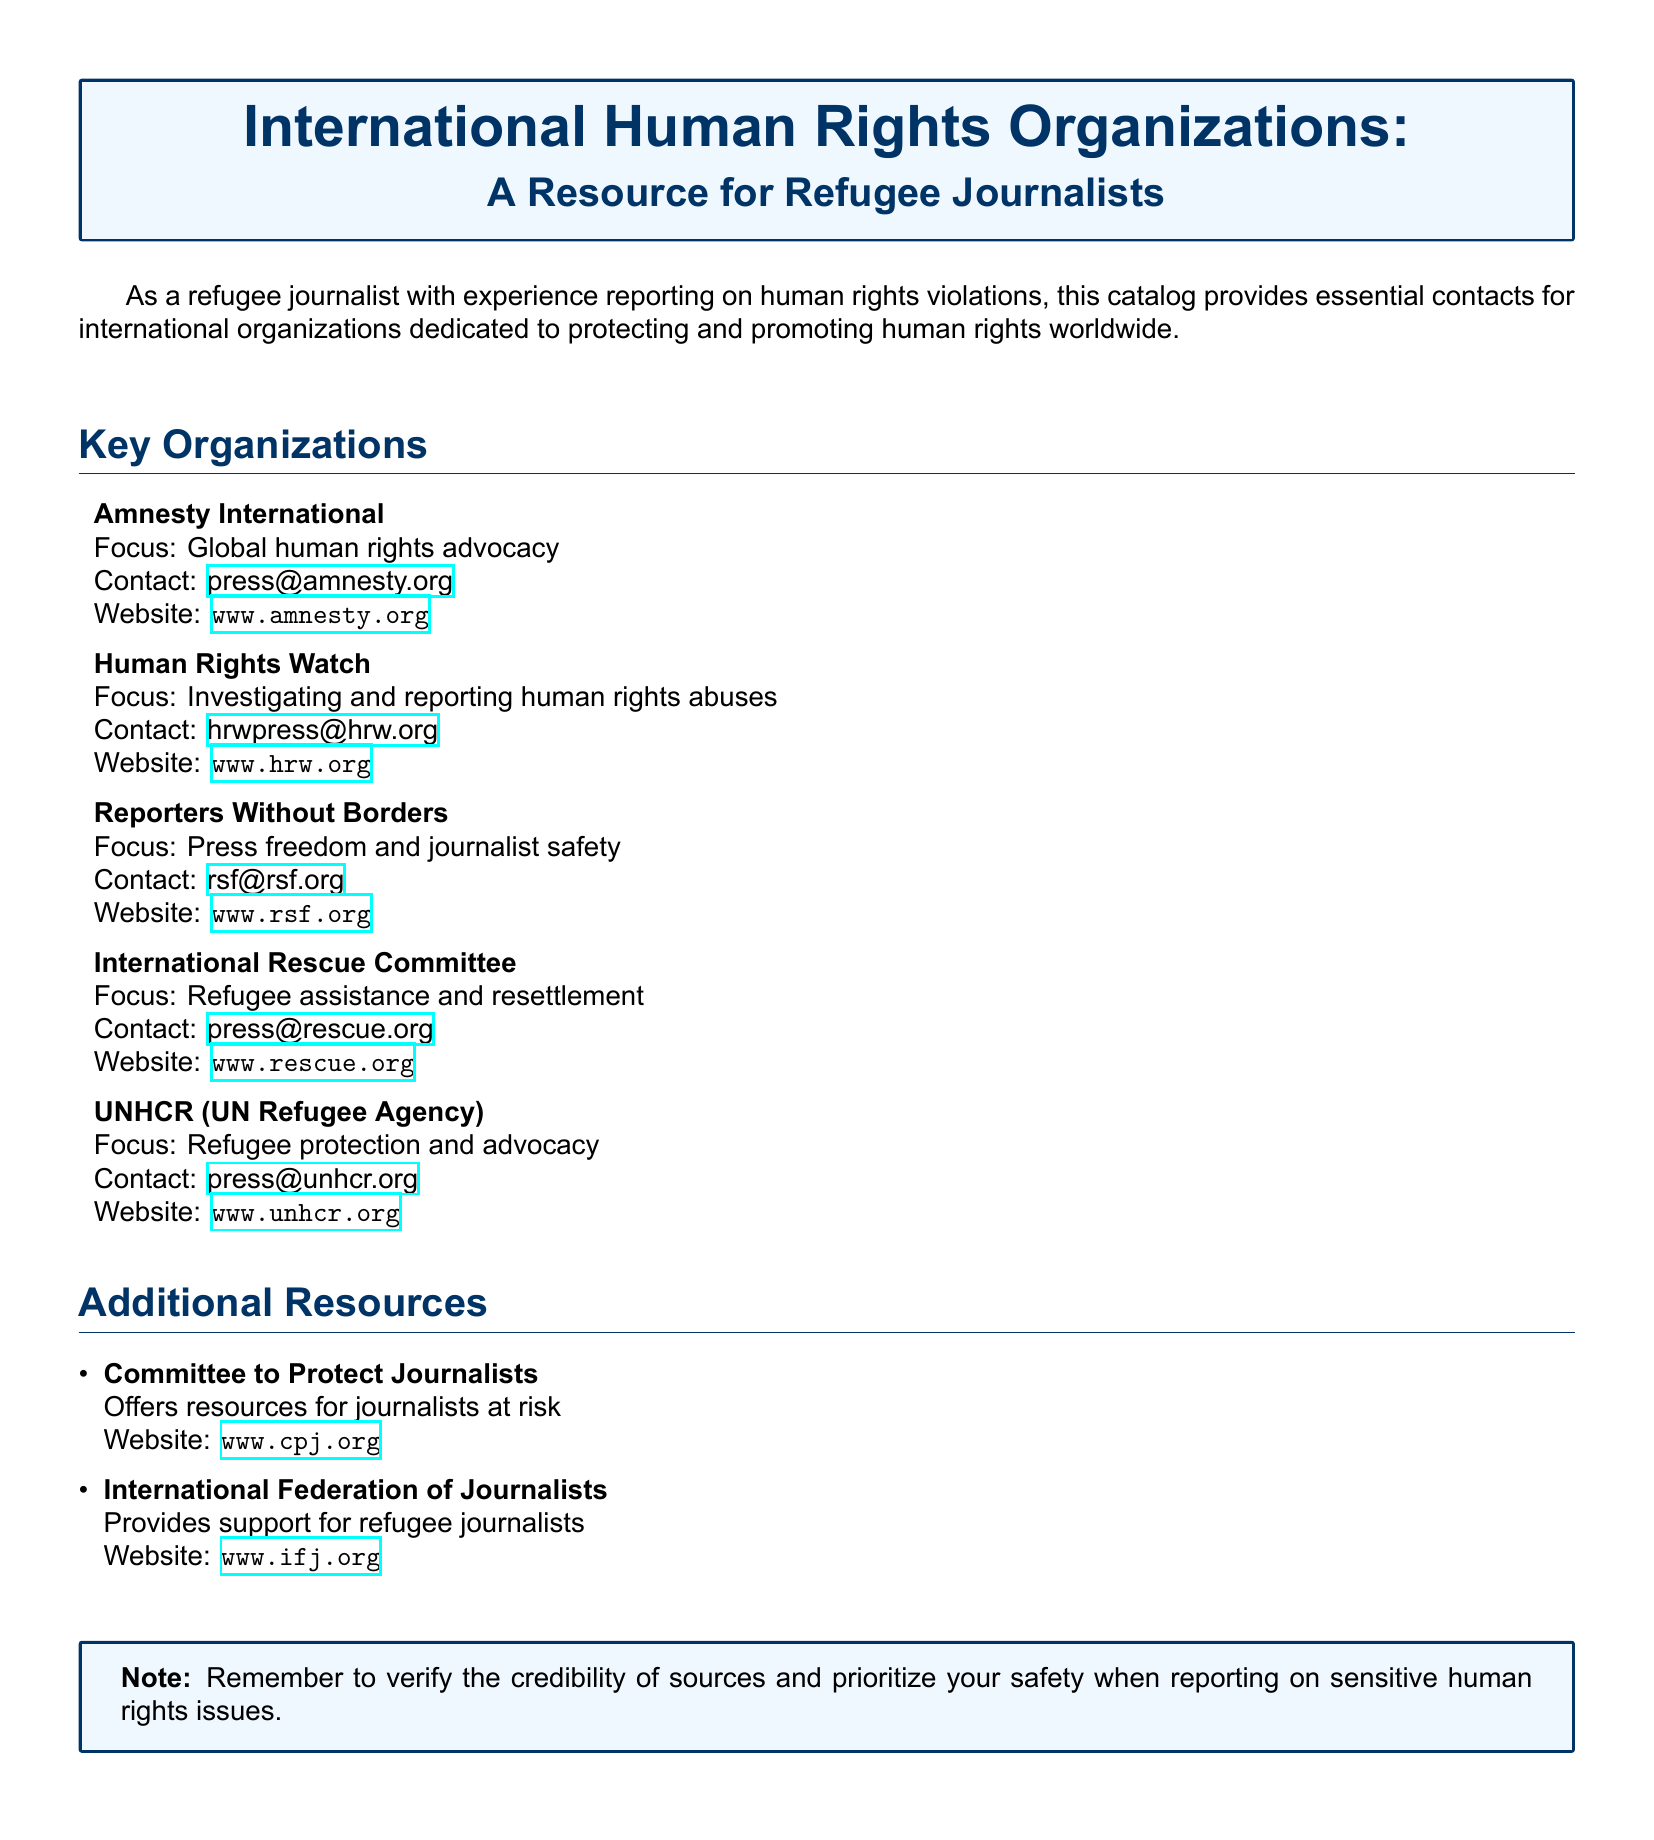What is the focus of Amnesty International? The focus of Amnesty International is global human rights advocacy.
Answer: Global human rights advocacy What is the contact email for Human Rights Watch? The contact email for Human Rights Watch is provided in the document.
Answer: hrwpress@hrw.org Which organization focuses on refugee protection? The organization that focuses on refugee protection is listed in the catalog.
Answer: UNHCR (UN Refugee Agency) How many key organizations are mentioned in the document? The document lists a specific number of key organizations under the "Key Organizations" section.
Answer: 5 What additional resources support refugee journalists? The document provides the names of organizations that offer additional resources for refugee journalists.
Answer: International Federation of Journalists What is the website for Reporters Without Borders? The website for Reporters Without Borders is included in the document.
Answer: www.rsf.org What is the main focus of the International Rescue Committee? The main focus of the International Rescue Committee is mentioned in the document.
Answer: Refugee assistance and resettlement Which organization is dedicated to press freedom? The organization dedicated to press freedom is specified in the catalog.
Answer: Reporters Without Borders 